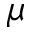<formula> <loc_0><loc_0><loc_500><loc_500>\mu</formula> 